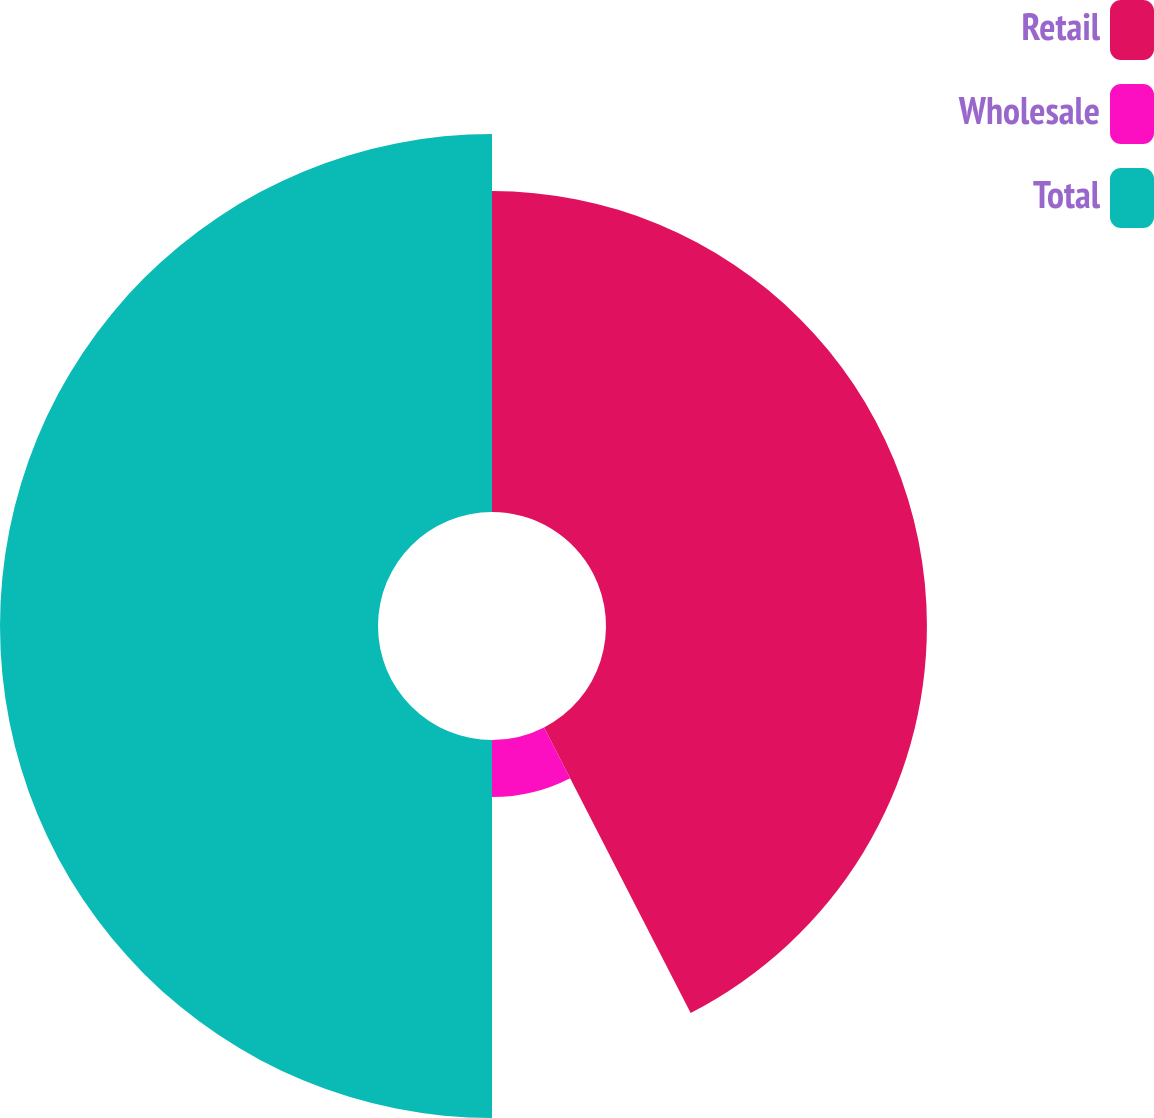Convert chart to OTSL. <chart><loc_0><loc_0><loc_500><loc_500><pie_chart><fcel>Retail<fcel>Wholesale<fcel>Total<nl><fcel>42.45%<fcel>7.55%<fcel>50.0%<nl></chart> 